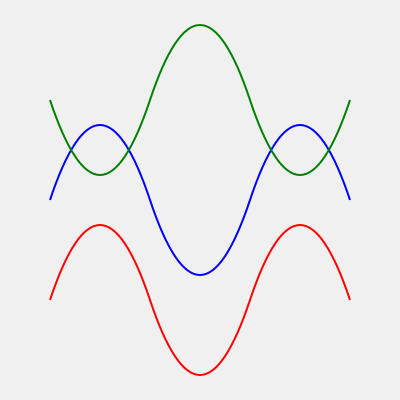Given the above representation of three strange attractors in a chaotic system, which attractor is most likely to exhibit the highest Lyapunov exponent, indicating stronger chaotic behavior? To determine which attractor exhibits the strongest chaotic behavior, we need to analyze the characteristics of each curve:

1. Blue curve (top):
   - Relatively smooth with gentle oscillations
   - Consistent wavelength and amplitude

2. Red curve (bottom):
   - More irregular oscillations
   - Varying wavelength and amplitude

3. Green curve (middle):
   - Highly irregular oscillations
   - Rapidly changing wavelength and amplitude

The Lyapunov exponent quantifies the rate of separation of infinitesimally close trajectories in a dynamical system. A higher Lyapunov exponent indicates stronger chaotic behavior.

Key factors to consider:
1. Irregularity: More irregular patterns suggest higher sensitivity to initial conditions, a hallmark of chaos.
2. Rapid changes: Faster changes in the system's behavior indicate a higher rate of divergence for nearby trajectories.

Analyzing the curves:
- The blue curve shows the least irregularity and change, suggesting the lowest Lyapunov exponent.
- The red curve shows more irregularity than the blue one but less than the green one.
- The green curve exhibits the most irregular pattern with rapid changes, indicating the highest sensitivity to initial conditions.

Therefore, the green curve (middle) is most likely to have the highest Lyapunov exponent and exhibit the strongest chaotic behavior.
Answer: Green (middle) curve 